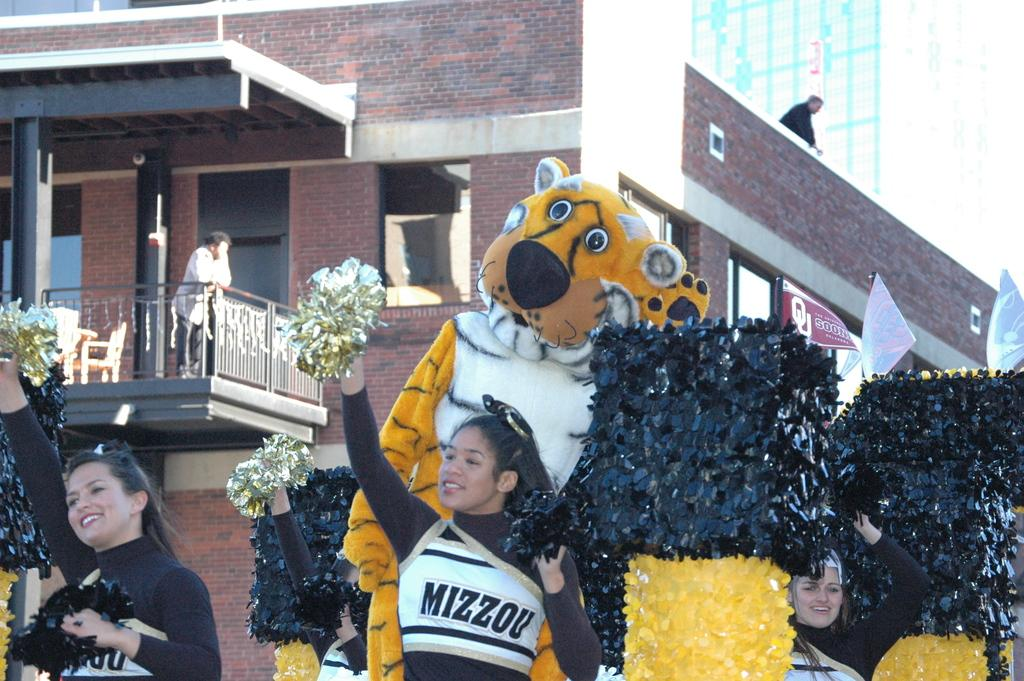<image>
Write a terse but informative summary of the picture. A group of cheerleaders are dancing by a tiger mascot and wearing uniforms that say Mizzou. 